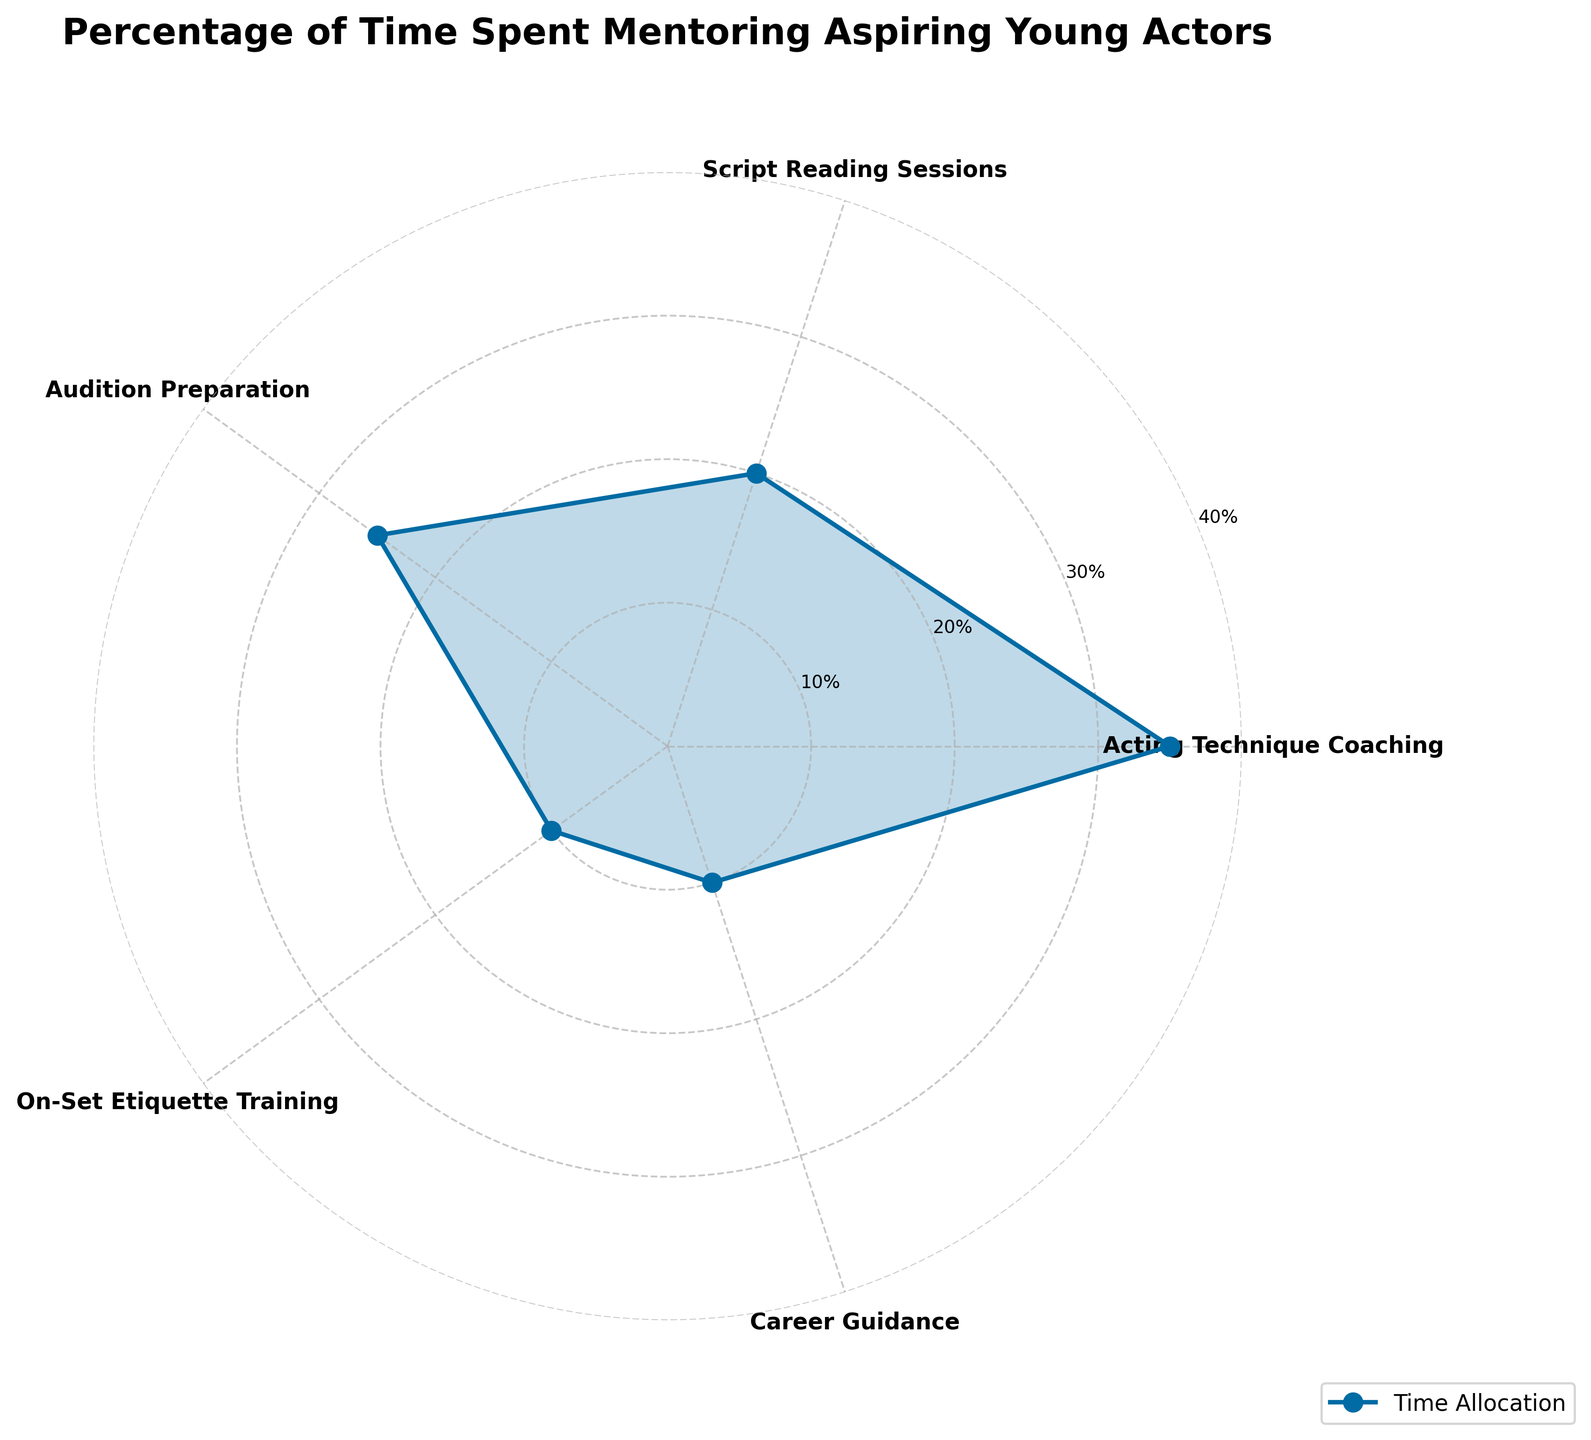What is the title of the figure? The title is located at the top of the figure and summarizes the content of the chart. It reads "Percentage of Time Spent Mentoring Aspiring Young Actors".
Answer: Percentage of Time Spent Mentoring Aspiring Young Actors How many different activities are displayed in the chart? The chart shows the activities around the polar axis. Counting the distinct labeled points, we see there are 5 different activities.
Answer: 5 Which activity has the highest percentage of time spent? The chart displays the percentage values along the radial lines. The highest radial value is 35%, which corresponds to "Acting Technique Coaching".
Answer: Acting Technique Coaching What is the total percentage of time spent on "Script Reading Sessions" and "Career Guidance"? Adding the percentages for "Script Reading Sessions" (20%) and "Career Guidance" (10%) gives 20% + 10% = 30%.
Answer: 30% How does the percentage of time spent on "Audition Preparation" compare to "On-Set Etiquette Training"? From the chart, "Audition Preparation" occupies 25% while "On-Set Etiquette Training" occupies 10%. Thus, "Audition Preparation" is greater by 25% - 10% = 15%.
Answer: 15% more Which activities share the same percentage of time spent? The chart shows two activities with equal radial lines at 10%: "On-Set Etiquette Training" and "Career Guidance".
Answer: On-Set Etiquette Training and Career Guidance What is the average percentage of time spent across all activities? The average is calculated by summing all the percentages and dividing by the number of activities: (35 + 20 + 25 + 10 + 10) / 5 = 100 / 5 = 20%.
Answer: 20% What is the range of percentages depicted in the chart? The range is the difference between the highest and lowest percentages. The highest is 35% and the lowest is 10%, so 35% - 10% = 25%.
Answer: 25% If 10 hours are spent mentoring in a week, how much time is dedicated to "Acting Technique Coaching"? "Acting Technique Coaching" accounts for 35% of the total time. To find the time, multiply 10 hours by 35%: 10 * 0.35 = 3.5 hours.
Answer: 3.5 hours 